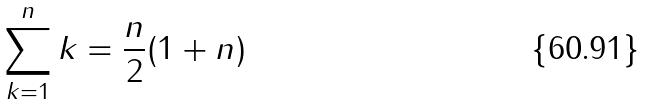Convert formula to latex. <formula><loc_0><loc_0><loc_500><loc_500>\sum _ { k = 1 } ^ { n } k = \frac { n } { 2 } ( 1 + n )</formula> 